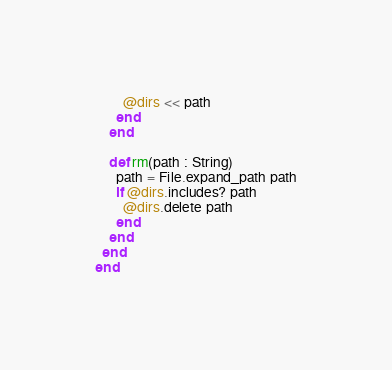Convert code to text. <code><loc_0><loc_0><loc_500><loc_500><_Crystal_>        @dirs << path
      end
    end

    def rm(path : String)
      path = File.expand_path path
      if @dirs.includes? path
        @dirs.delete path
      end
    end
  end
end
</code> 